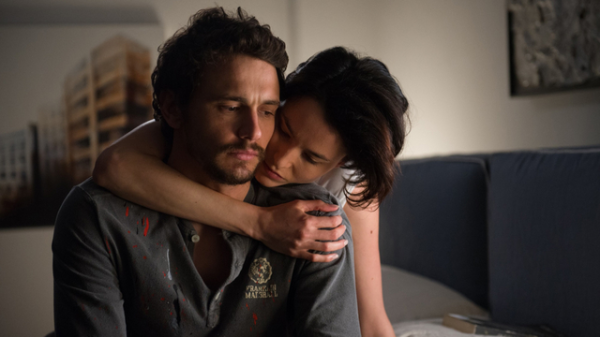What details can you provide about the attire of the individuals in the image? The man is dressed in a grey collared shirt, slightly dishevelled and stained with red marks, which could be blood, indicating recent physical strain or conflict. His badge reads 'Marshal', pointing to his official duty and responsibilities. The woman wears a simple black top, which contrasts with the man's more distressed appearance, adding to the emotional weight of her comforting gesture. How do the physical expressions of the individuals contribute to the story this image might be telling? The man's closed eyes and the slight frown on his face reveal an emotional or physical exhaustion, perhaps from his professional duties. The woman, with her soothing expression and the way her body leans into him, shows a deep concern and a desire to provide solace. These expressions and postures heighten the narrative of a poignant moment where support and empathy are being exchanged, emphasizing a narrative of personal struggle tempered by close, trusting relationships. 